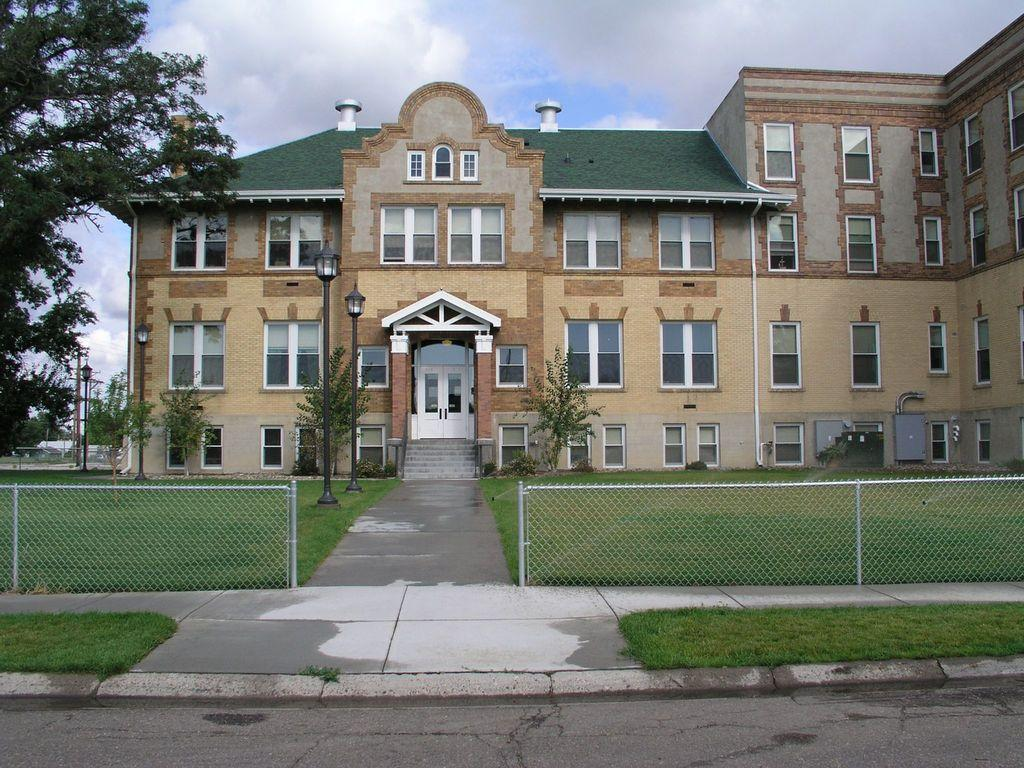What type of structures can be seen in the image? There are fences, a road, and at least one building visible in the image. What is the ground surface like in the image? Grass is present on the ground in the image. What type of lighting is present in the image? Light poles are visible in the image. What type of vegetation is present in the image? Trees are present in the image. How many buildings are visible in the image? There is at least one building visible in the image. What architectural features can be seen on the building? Windows and doors are visible on the building in the image. What type of steps are present in the image? Steps are visible in the image. What type of materials are present in the image? Metal objects are present in the image. What is visible in the sky in the image? Clouds are visible in the sky in the image. How many toes can be seen on the sponge in the image? There is no sponge present in the image, and therefore no toes can be seen on it. What type of watch is visible on the tree in the image? There is no watch present in the image, and the tree does not have any visible watches. 